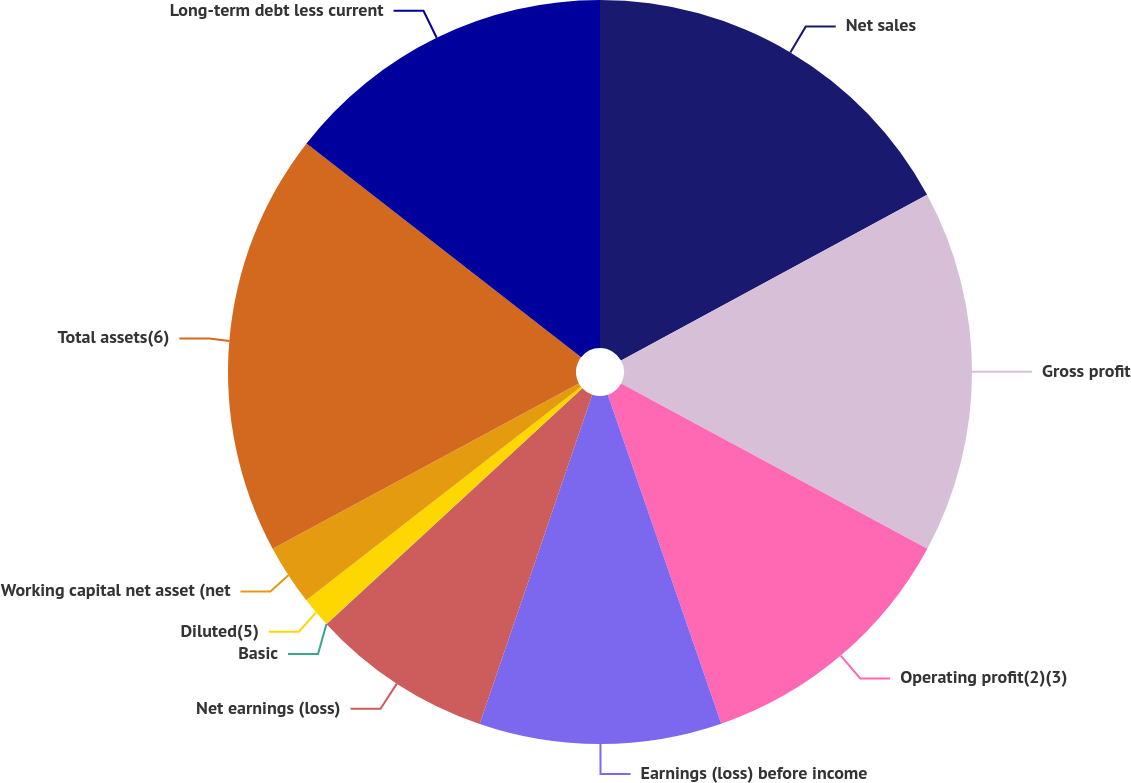Convert chart. <chart><loc_0><loc_0><loc_500><loc_500><pie_chart><fcel>Net sales<fcel>Gross profit<fcel>Operating profit(2)(3)<fcel>Earnings (loss) before income<fcel>Net earnings (loss)<fcel>Basic<fcel>Diluted(5)<fcel>Working capital net asset (net<fcel>Total assets(6)<fcel>Long-term debt less current<nl><fcel>17.1%<fcel>15.78%<fcel>11.84%<fcel>10.53%<fcel>7.9%<fcel>0.01%<fcel>1.33%<fcel>2.64%<fcel>18.41%<fcel>14.47%<nl></chart> 